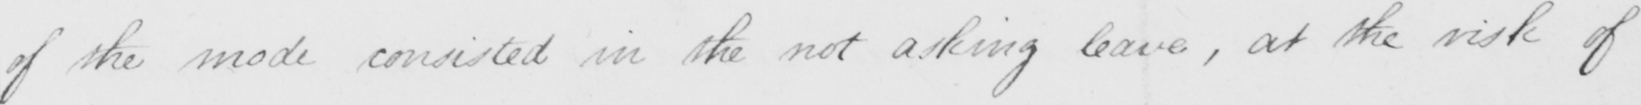Can you tell me what this handwritten text says? of the mode consisted in the not asking leave , at the risk of 